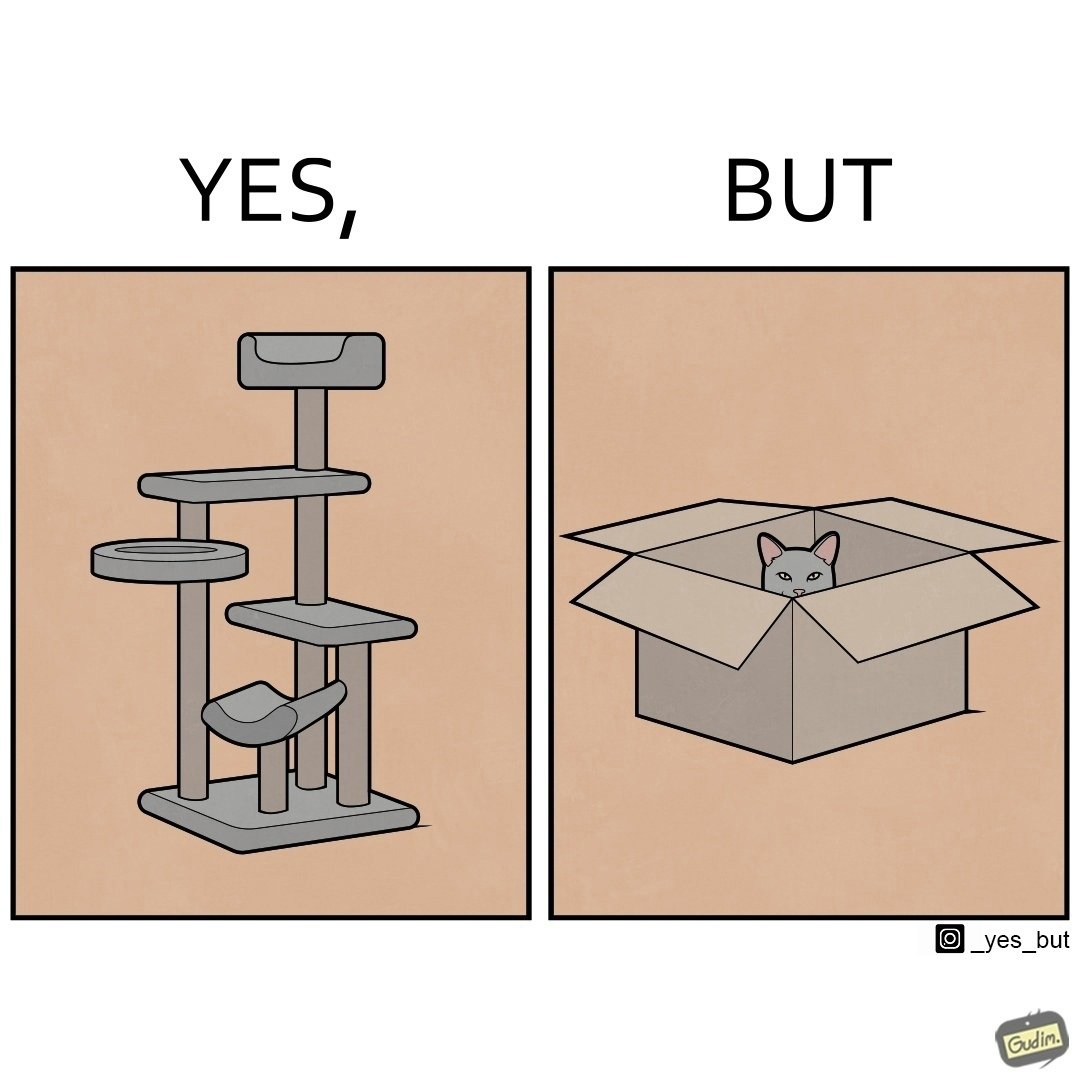What does this image depict? The images are funny since even though a cat tree is bought for cats to play with, cats would usually rather play with inexpensive cardboard boxes because they enjoy it more 